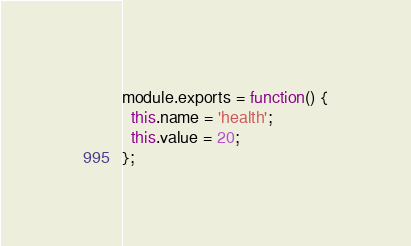<code> <loc_0><loc_0><loc_500><loc_500><_JavaScript_>module.exports = function() {
  this.name = 'health';
  this.value = 20;
};

</code> 